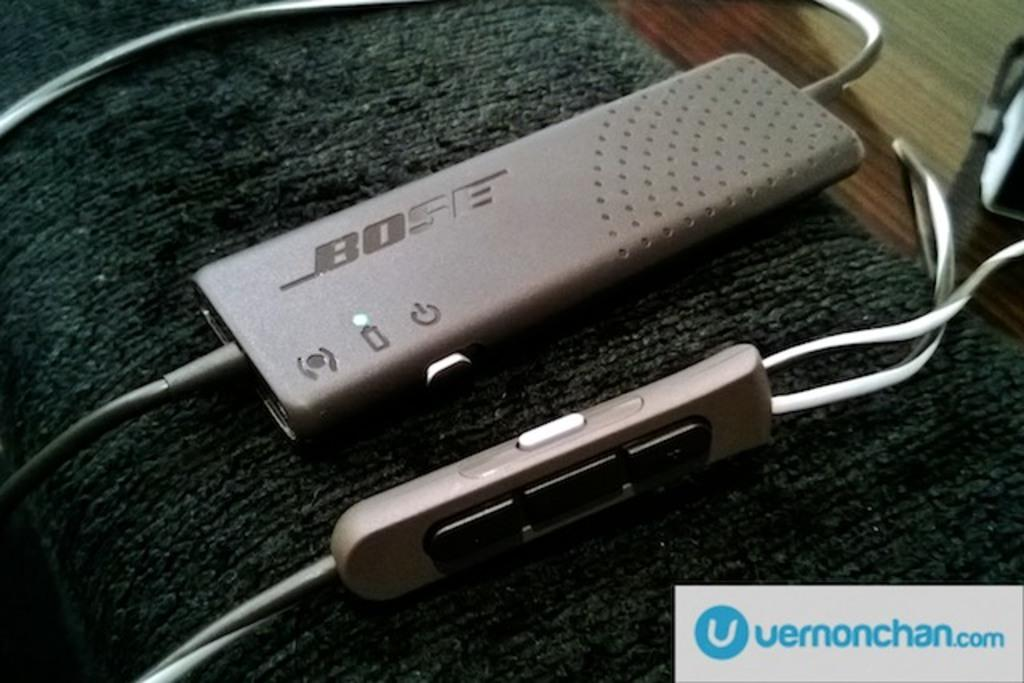Provide a one-sentence caption for the provided image. A small electronic device by Bose sits on a plush arm rest. 